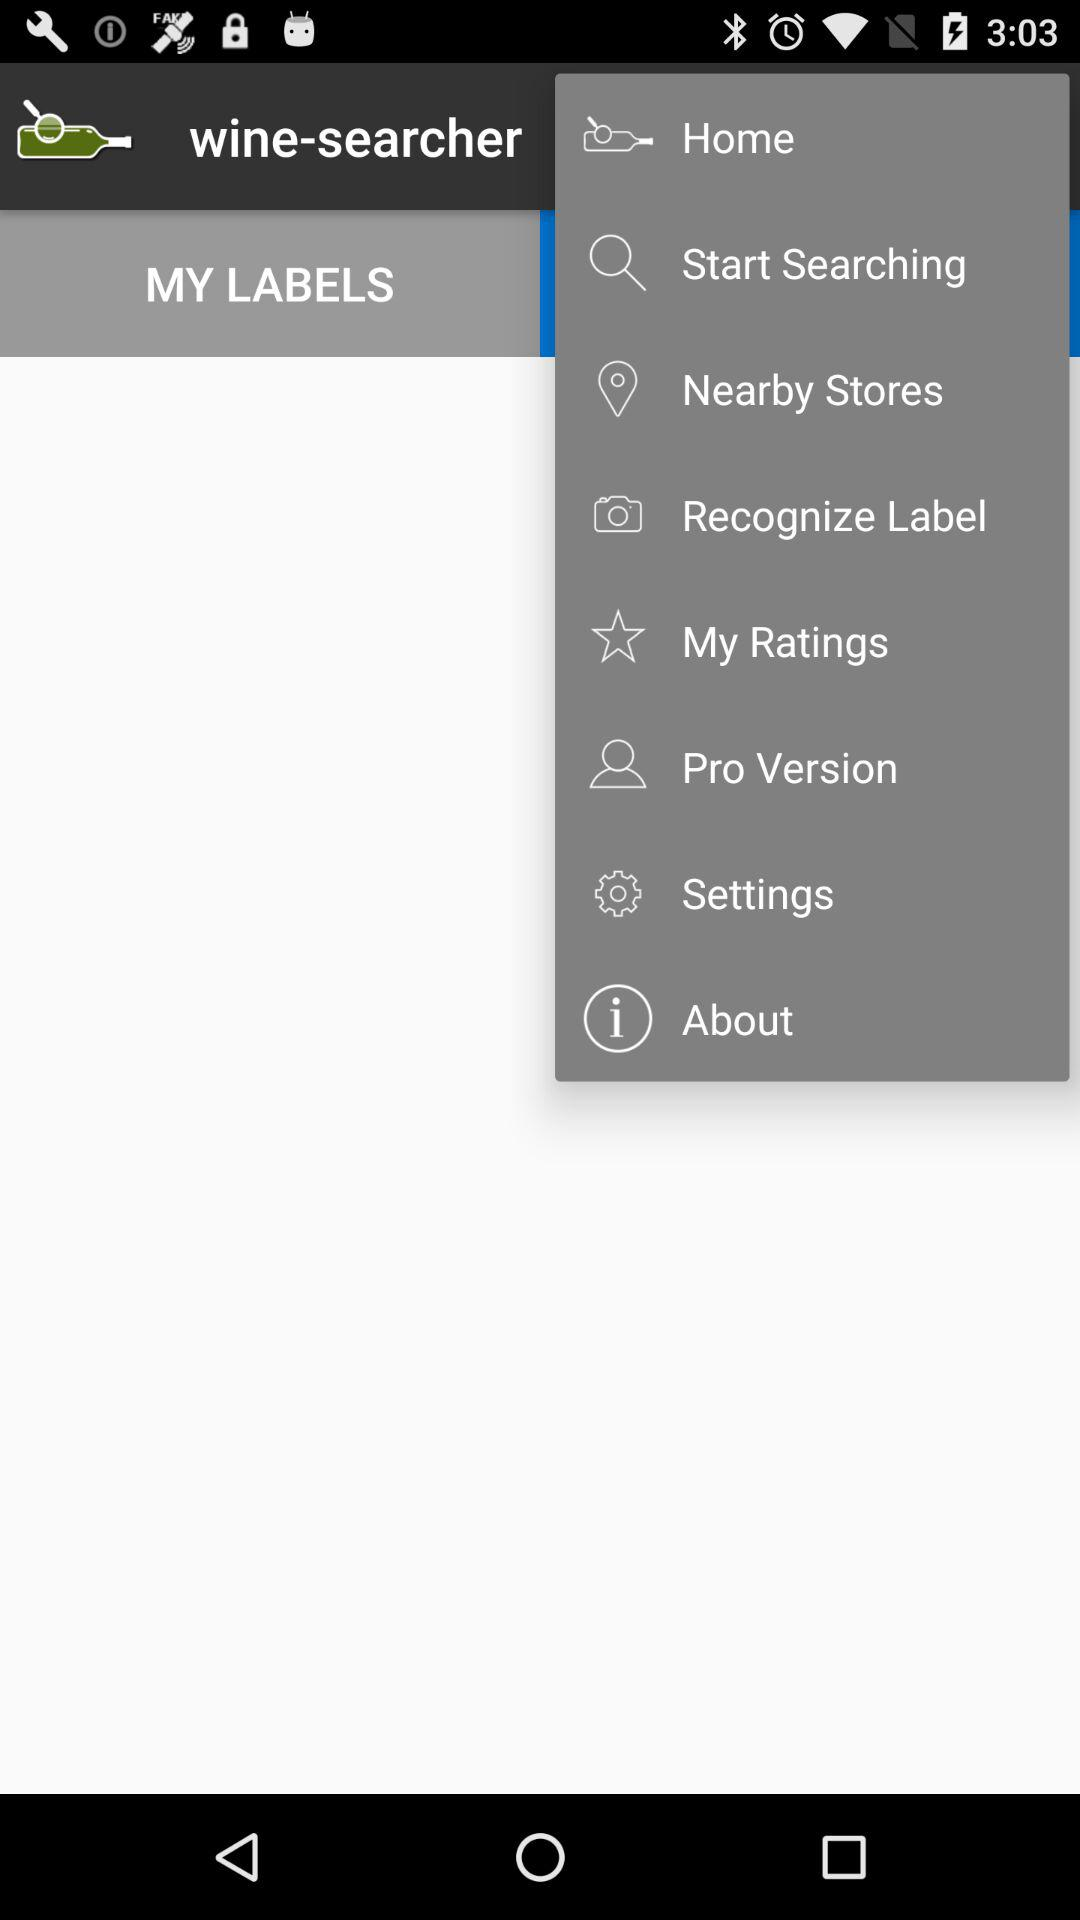Which is the selected option?
When the provided information is insufficient, respond with <no answer>. <no answer> 